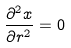<formula> <loc_0><loc_0><loc_500><loc_500>\frac { \partial ^ { 2 } x } { \partial r ^ { 2 } } = 0</formula> 